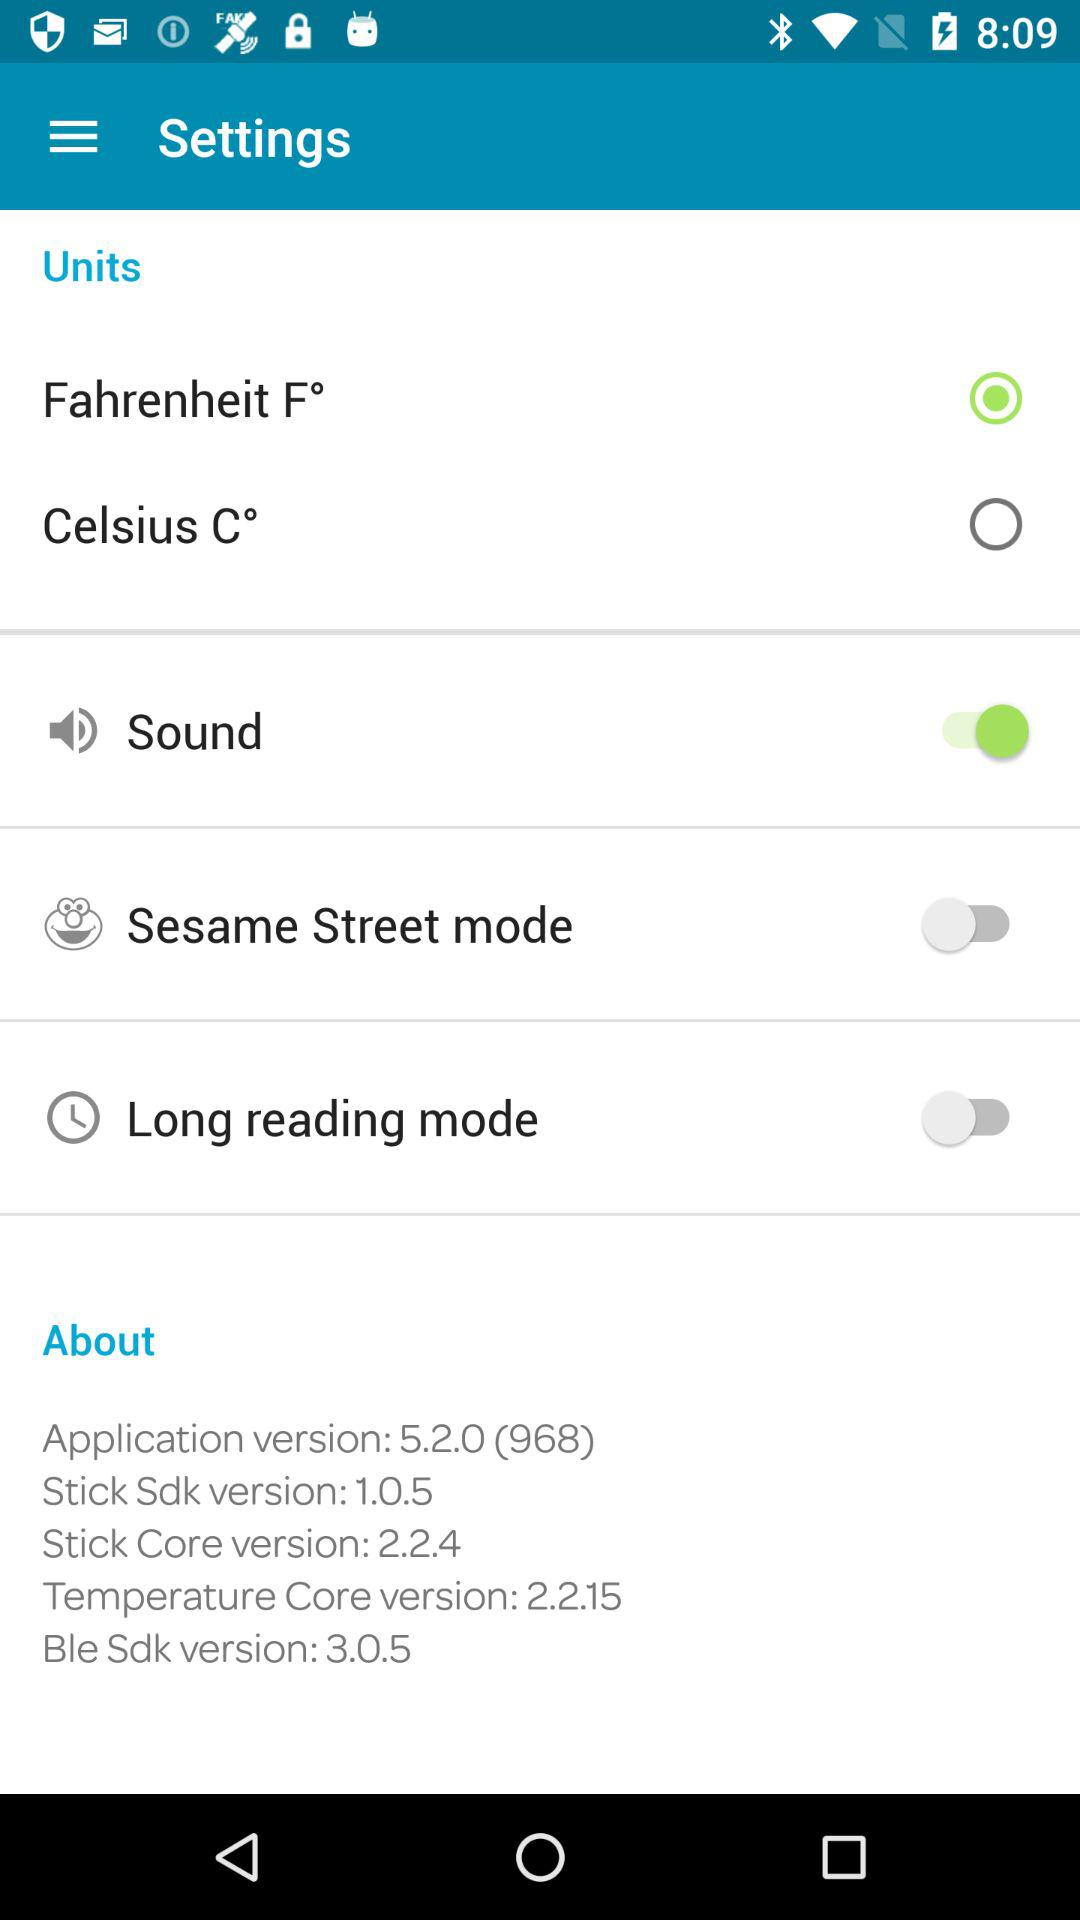What version of the temperature core is used? The version is 2.2.15. 